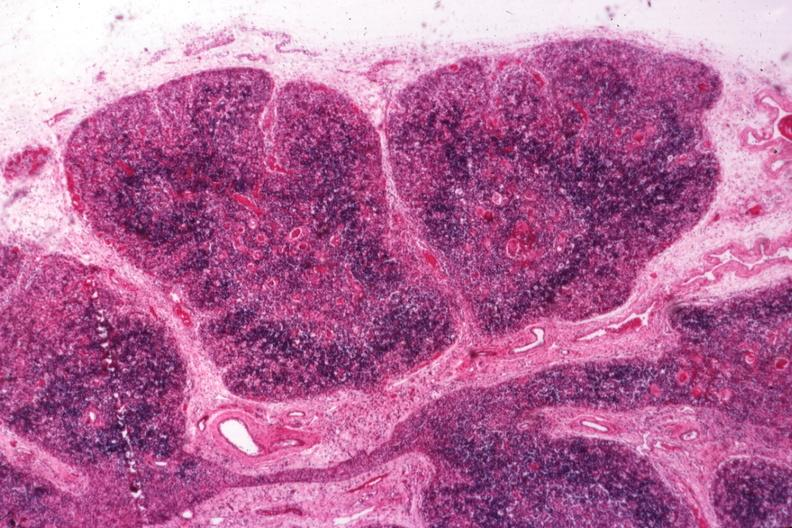s opened muscle present?
Answer the question using a single word or phrase. No 